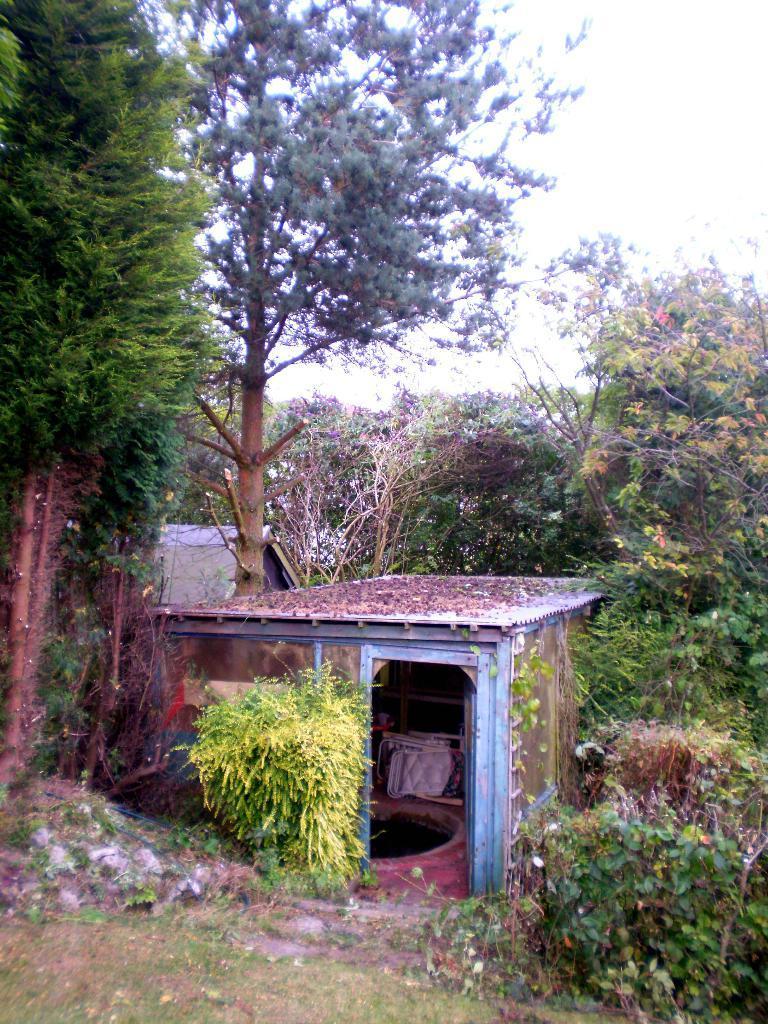How would you summarize this image in a sentence or two? In this picture we can see a house, in the background there are some trees, we can see grass and plants at the bottom, there is the sky at the top of the picture. 